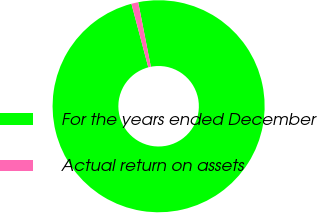Convert chart to OTSL. <chart><loc_0><loc_0><loc_500><loc_500><pie_chart><fcel>For the years ended December<fcel>Actual return on assets<nl><fcel>98.96%<fcel>1.04%<nl></chart> 